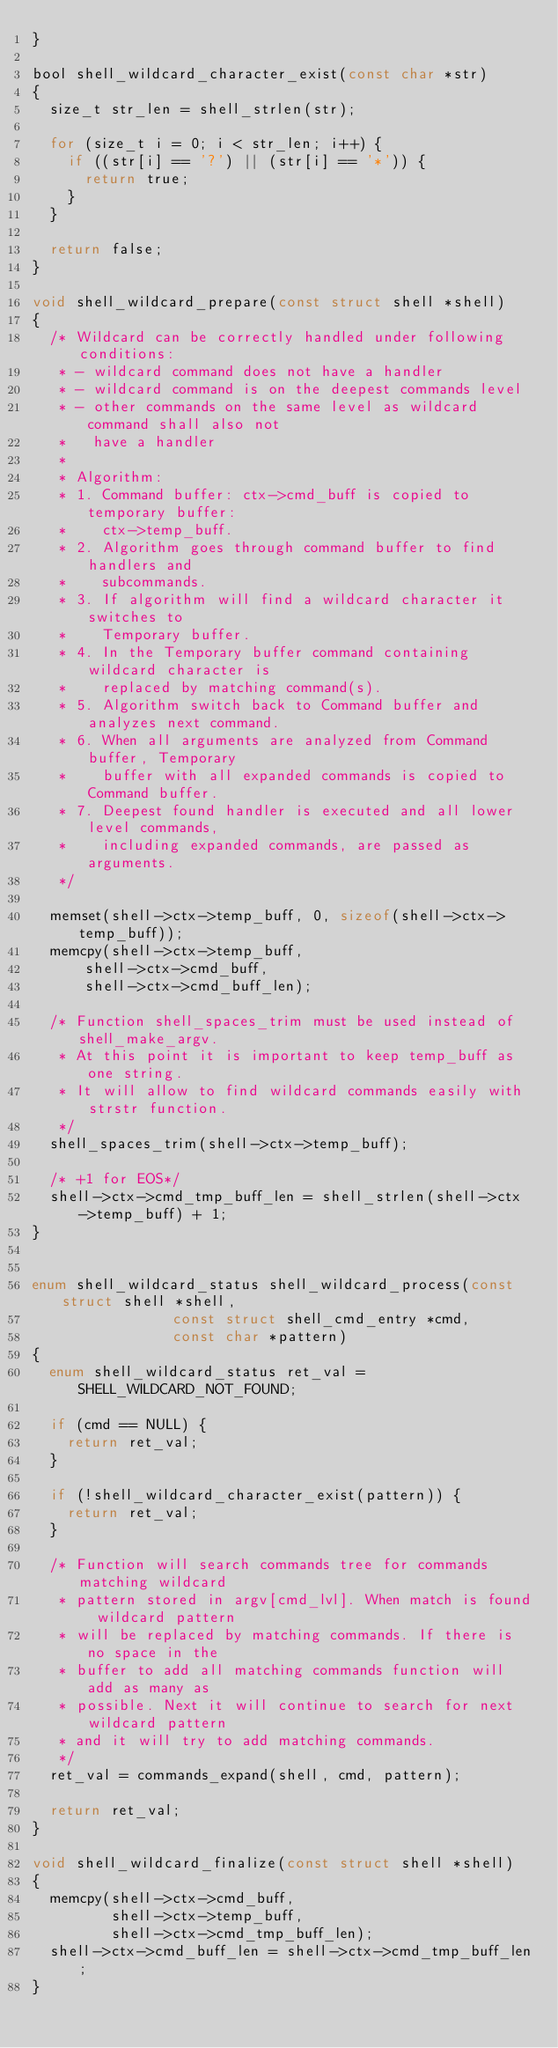Convert code to text. <code><loc_0><loc_0><loc_500><loc_500><_C_>}

bool shell_wildcard_character_exist(const char *str)
{
	size_t str_len = shell_strlen(str);

	for (size_t i = 0; i < str_len; i++) {
		if ((str[i] == '?') || (str[i] == '*')) {
			return true;
		}
	}

	return false;
}

void shell_wildcard_prepare(const struct shell *shell)
{
	/* Wildcard can be correctly handled under following conditions:
	 * - wildcard command does not have a handler
	 * - wildcard command is on the deepest commands level
	 * - other commands on the same level as wildcard command shall also not
	 *   have a handler
	 *
	 * Algorithm:
	 * 1. Command buffer: ctx->cmd_buff is copied to temporary buffer:
	 *    ctx->temp_buff.
	 * 2. Algorithm goes through command buffer to find handlers and
	 *    subcommands.
	 * 3. If algorithm will find a wildcard character it switches to
	 *    Temporary buffer.
	 * 4. In the Temporary buffer command containing wildcard character is
	 *    replaced by matching command(s).
	 * 5. Algorithm switch back to Command buffer and analyzes next command.
	 * 6. When all arguments are analyzed from Command buffer, Temporary
	 *    buffer with all expanded commands is copied to Command buffer.
	 * 7. Deepest found handler is executed and all lower level commands,
	 *    including expanded commands, are passed as arguments.
	 */

	memset(shell->ctx->temp_buff, 0, sizeof(shell->ctx->temp_buff));
	memcpy(shell->ctx->temp_buff,
			shell->ctx->cmd_buff,
			shell->ctx->cmd_buff_len);

	/* Function shell_spaces_trim must be used instead of shell_make_argv.
	 * At this point it is important to keep temp_buff as one string.
	 * It will allow to find wildcard commands easily with strstr function.
	 */
	shell_spaces_trim(shell->ctx->temp_buff);

	/* +1 for EOS*/
	shell->ctx->cmd_tmp_buff_len = shell_strlen(shell->ctx->temp_buff) + 1;
}


enum shell_wildcard_status shell_wildcard_process(const struct shell *shell,
					      const struct shell_cmd_entry *cmd,
					      const char *pattern)
{
	enum shell_wildcard_status ret_val = SHELL_WILDCARD_NOT_FOUND;

	if (cmd == NULL) {
		return ret_val;
	}

	if (!shell_wildcard_character_exist(pattern)) {
		return ret_val;
	}

	/* Function will search commands tree for commands matching wildcard
	 * pattern stored in argv[cmd_lvl]. When match is found wildcard pattern
	 * will be replaced by matching commands. If there is no space in the
	 * buffer to add all matching commands function will add as many as
	 * possible. Next it will continue to search for next wildcard pattern
	 * and it will try to add matching commands.
	 */
	ret_val = commands_expand(shell, cmd, pattern);

	return ret_val;
}

void shell_wildcard_finalize(const struct shell *shell)
{
	memcpy(shell->ctx->cmd_buff,
	       shell->ctx->temp_buff,
	       shell->ctx->cmd_tmp_buff_len);
	shell->ctx->cmd_buff_len = shell->ctx->cmd_tmp_buff_len;
}
</code> 